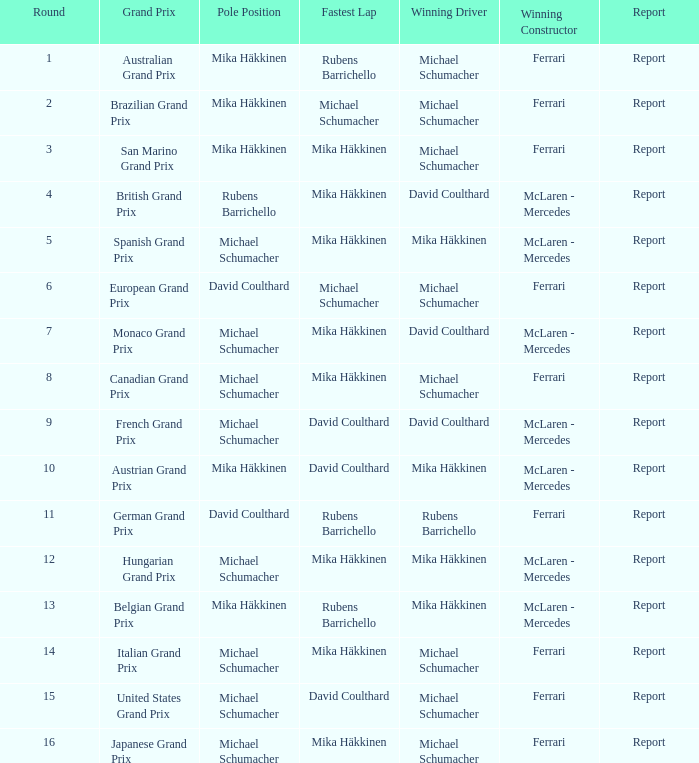How many drivers won the Italian Grand Prix? 1.0. 